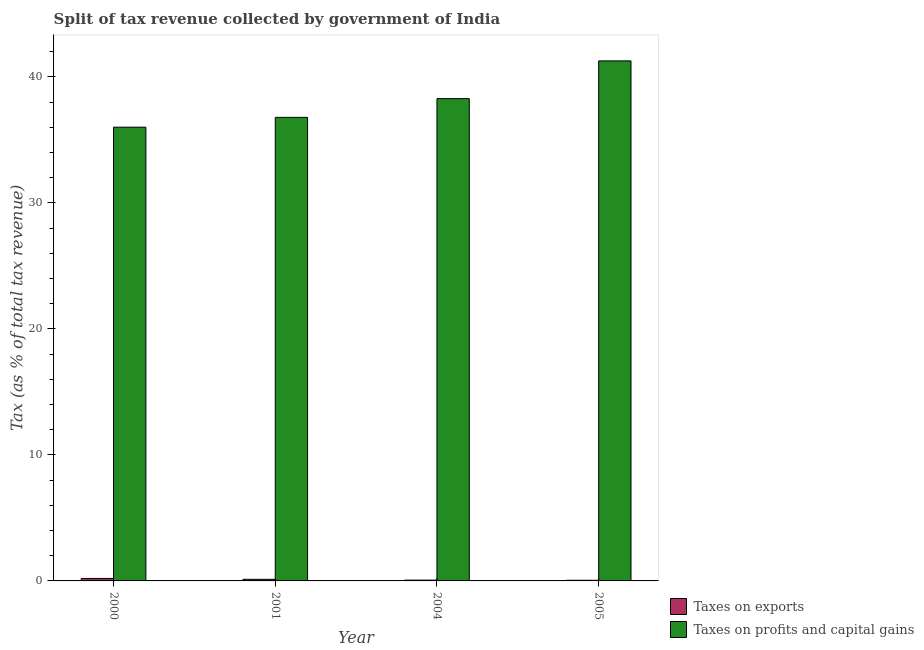How many different coloured bars are there?
Make the answer very short. 2. How many groups of bars are there?
Your response must be concise. 4. Are the number of bars per tick equal to the number of legend labels?
Your response must be concise. Yes. Are the number of bars on each tick of the X-axis equal?
Make the answer very short. Yes. How many bars are there on the 1st tick from the left?
Your response must be concise. 2. How many bars are there on the 4th tick from the right?
Make the answer very short. 2. What is the percentage of revenue obtained from taxes on profits and capital gains in 2000?
Your response must be concise. 36. Across all years, what is the maximum percentage of revenue obtained from taxes on profits and capital gains?
Offer a terse response. 41.26. Across all years, what is the minimum percentage of revenue obtained from taxes on exports?
Ensure brevity in your answer.  0.05. In which year was the percentage of revenue obtained from taxes on profits and capital gains maximum?
Offer a very short reply. 2005. What is the total percentage of revenue obtained from taxes on exports in the graph?
Your answer should be compact. 0.43. What is the difference between the percentage of revenue obtained from taxes on exports in 2000 and that in 2004?
Your answer should be compact. 0.13. What is the difference between the percentage of revenue obtained from taxes on exports in 2004 and the percentage of revenue obtained from taxes on profits and capital gains in 2000?
Provide a short and direct response. -0.13. What is the average percentage of revenue obtained from taxes on profits and capital gains per year?
Offer a very short reply. 38.08. In the year 2004, what is the difference between the percentage of revenue obtained from taxes on exports and percentage of revenue obtained from taxes on profits and capital gains?
Provide a short and direct response. 0. What is the ratio of the percentage of revenue obtained from taxes on exports in 2004 to that in 2005?
Offer a very short reply. 1.21. Is the percentage of revenue obtained from taxes on exports in 2001 less than that in 2004?
Keep it short and to the point. No. What is the difference between the highest and the second highest percentage of revenue obtained from taxes on exports?
Offer a very short reply. 0.07. What is the difference between the highest and the lowest percentage of revenue obtained from taxes on profits and capital gains?
Your answer should be compact. 5.26. In how many years, is the percentage of revenue obtained from taxes on exports greater than the average percentage of revenue obtained from taxes on exports taken over all years?
Keep it short and to the point. 2. What does the 1st bar from the left in 2004 represents?
Your answer should be very brief. Taxes on exports. What does the 1st bar from the right in 2004 represents?
Offer a terse response. Taxes on profits and capital gains. How many bars are there?
Give a very brief answer. 8. How many legend labels are there?
Offer a terse response. 2. How are the legend labels stacked?
Ensure brevity in your answer.  Vertical. What is the title of the graph?
Keep it short and to the point. Split of tax revenue collected by government of India. What is the label or title of the X-axis?
Provide a succinct answer. Year. What is the label or title of the Y-axis?
Your response must be concise. Tax (as % of total tax revenue). What is the Tax (as % of total tax revenue) in Taxes on exports in 2000?
Give a very brief answer. 0.2. What is the Tax (as % of total tax revenue) of Taxes on profits and capital gains in 2000?
Offer a terse response. 36. What is the Tax (as % of total tax revenue) of Taxes on exports in 2001?
Provide a short and direct response. 0.13. What is the Tax (as % of total tax revenue) in Taxes on profits and capital gains in 2001?
Your answer should be very brief. 36.78. What is the Tax (as % of total tax revenue) in Taxes on exports in 2004?
Ensure brevity in your answer.  0.06. What is the Tax (as % of total tax revenue) of Taxes on profits and capital gains in 2004?
Provide a succinct answer. 38.27. What is the Tax (as % of total tax revenue) in Taxes on exports in 2005?
Provide a succinct answer. 0.05. What is the Tax (as % of total tax revenue) in Taxes on profits and capital gains in 2005?
Ensure brevity in your answer.  41.26. Across all years, what is the maximum Tax (as % of total tax revenue) in Taxes on exports?
Keep it short and to the point. 0.2. Across all years, what is the maximum Tax (as % of total tax revenue) of Taxes on profits and capital gains?
Make the answer very short. 41.26. Across all years, what is the minimum Tax (as % of total tax revenue) of Taxes on exports?
Provide a succinct answer. 0.05. Across all years, what is the minimum Tax (as % of total tax revenue) in Taxes on profits and capital gains?
Keep it short and to the point. 36. What is the total Tax (as % of total tax revenue) of Taxes on exports in the graph?
Provide a short and direct response. 0.43. What is the total Tax (as % of total tax revenue) in Taxes on profits and capital gains in the graph?
Provide a succinct answer. 152.32. What is the difference between the Tax (as % of total tax revenue) of Taxes on exports in 2000 and that in 2001?
Your answer should be compact. 0.07. What is the difference between the Tax (as % of total tax revenue) of Taxes on profits and capital gains in 2000 and that in 2001?
Keep it short and to the point. -0.78. What is the difference between the Tax (as % of total tax revenue) of Taxes on exports in 2000 and that in 2004?
Provide a short and direct response. 0.13. What is the difference between the Tax (as % of total tax revenue) of Taxes on profits and capital gains in 2000 and that in 2004?
Make the answer very short. -2.27. What is the difference between the Tax (as % of total tax revenue) in Taxes on exports in 2000 and that in 2005?
Your answer should be very brief. 0.14. What is the difference between the Tax (as % of total tax revenue) of Taxes on profits and capital gains in 2000 and that in 2005?
Your response must be concise. -5.26. What is the difference between the Tax (as % of total tax revenue) in Taxes on exports in 2001 and that in 2004?
Your response must be concise. 0.06. What is the difference between the Tax (as % of total tax revenue) in Taxes on profits and capital gains in 2001 and that in 2004?
Your answer should be very brief. -1.49. What is the difference between the Tax (as % of total tax revenue) of Taxes on exports in 2001 and that in 2005?
Ensure brevity in your answer.  0.08. What is the difference between the Tax (as % of total tax revenue) of Taxes on profits and capital gains in 2001 and that in 2005?
Provide a short and direct response. -4.48. What is the difference between the Tax (as % of total tax revenue) in Taxes on exports in 2004 and that in 2005?
Offer a very short reply. 0.01. What is the difference between the Tax (as % of total tax revenue) of Taxes on profits and capital gains in 2004 and that in 2005?
Keep it short and to the point. -2.99. What is the difference between the Tax (as % of total tax revenue) of Taxes on exports in 2000 and the Tax (as % of total tax revenue) of Taxes on profits and capital gains in 2001?
Offer a terse response. -36.59. What is the difference between the Tax (as % of total tax revenue) in Taxes on exports in 2000 and the Tax (as % of total tax revenue) in Taxes on profits and capital gains in 2004?
Keep it short and to the point. -38.07. What is the difference between the Tax (as % of total tax revenue) of Taxes on exports in 2000 and the Tax (as % of total tax revenue) of Taxes on profits and capital gains in 2005?
Ensure brevity in your answer.  -41.07. What is the difference between the Tax (as % of total tax revenue) in Taxes on exports in 2001 and the Tax (as % of total tax revenue) in Taxes on profits and capital gains in 2004?
Your answer should be compact. -38.14. What is the difference between the Tax (as % of total tax revenue) of Taxes on exports in 2001 and the Tax (as % of total tax revenue) of Taxes on profits and capital gains in 2005?
Ensure brevity in your answer.  -41.14. What is the difference between the Tax (as % of total tax revenue) of Taxes on exports in 2004 and the Tax (as % of total tax revenue) of Taxes on profits and capital gains in 2005?
Offer a terse response. -41.2. What is the average Tax (as % of total tax revenue) of Taxes on exports per year?
Offer a very short reply. 0.11. What is the average Tax (as % of total tax revenue) of Taxes on profits and capital gains per year?
Your response must be concise. 38.08. In the year 2000, what is the difference between the Tax (as % of total tax revenue) of Taxes on exports and Tax (as % of total tax revenue) of Taxes on profits and capital gains?
Make the answer very short. -35.81. In the year 2001, what is the difference between the Tax (as % of total tax revenue) in Taxes on exports and Tax (as % of total tax revenue) in Taxes on profits and capital gains?
Ensure brevity in your answer.  -36.65. In the year 2004, what is the difference between the Tax (as % of total tax revenue) in Taxes on exports and Tax (as % of total tax revenue) in Taxes on profits and capital gains?
Make the answer very short. -38.21. In the year 2005, what is the difference between the Tax (as % of total tax revenue) of Taxes on exports and Tax (as % of total tax revenue) of Taxes on profits and capital gains?
Keep it short and to the point. -41.21. What is the ratio of the Tax (as % of total tax revenue) in Taxes on exports in 2000 to that in 2001?
Your response must be concise. 1.54. What is the ratio of the Tax (as % of total tax revenue) in Taxes on profits and capital gains in 2000 to that in 2001?
Ensure brevity in your answer.  0.98. What is the ratio of the Tax (as % of total tax revenue) of Taxes on exports in 2000 to that in 2004?
Your response must be concise. 3.15. What is the ratio of the Tax (as % of total tax revenue) of Taxes on profits and capital gains in 2000 to that in 2004?
Ensure brevity in your answer.  0.94. What is the ratio of the Tax (as % of total tax revenue) in Taxes on exports in 2000 to that in 2005?
Your answer should be very brief. 3.82. What is the ratio of the Tax (as % of total tax revenue) in Taxes on profits and capital gains in 2000 to that in 2005?
Keep it short and to the point. 0.87. What is the ratio of the Tax (as % of total tax revenue) of Taxes on exports in 2001 to that in 2004?
Offer a terse response. 2.04. What is the ratio of the Tax (as % of total tax revenue) in Taxes on profits and capital gains in 2001 to that in 2004?
Give a very brief answer. 0.96. What is the ratio of the Tax (as % of total tax revenue) of Taxes on exports in 2001 to that in 2005?
Your response must be concise. 2.48. What is the ratio of the Tax (as % of total tax revenue) of Taxes on profits and capital gains in 2001 to that in 2005?
Ensure brevity in your answer.  0.89. What is the ratio of the Tax (as % of total tax revenue) of Taxes on exports in 2004 to that in 2005?
Make the answer very short. 1.21. What is the ratio of the Tax (as % of total tax revenue) of Taxes on profits and capital gains in 2004 to that in 2005?
Your response must be concise. 0.93. What is the difference between the highest and the second highest Tax (as % of total tax revenue) of Taxes on exports?
Offer a very short reply. 0.07. What is the difference between the highest and the second highest Tax (as % of total tax revenue) in Taxes on profits and capital gains?
Provide a succinct answer. 2.99. What is the difference between the highest and the lowest Tax (as % of total tax revenue) of Taxes on exports?
Keep it short and to the point. 0.14. What is the difference between the highest and the lowest Tax (as % of total tax revenue) of Taxes on profits and capital gains?
Offer a very short reply. 5.26. 